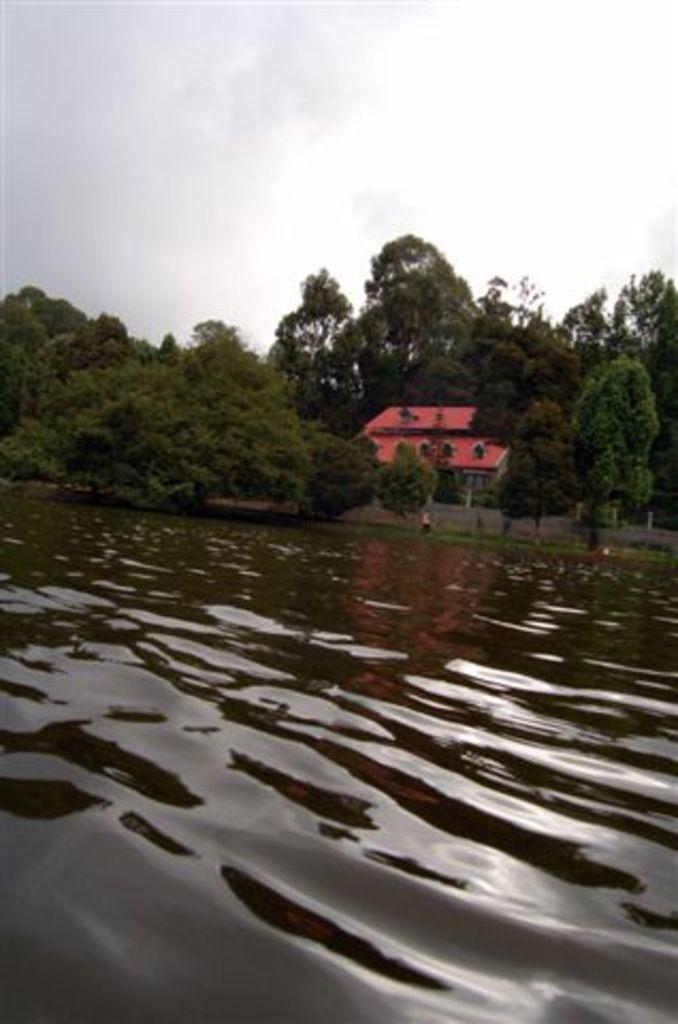Could you give a brief overview of what you see in this image? In this image I can see water. Background I can see building in orange color, trees in green color and sky in white color. 